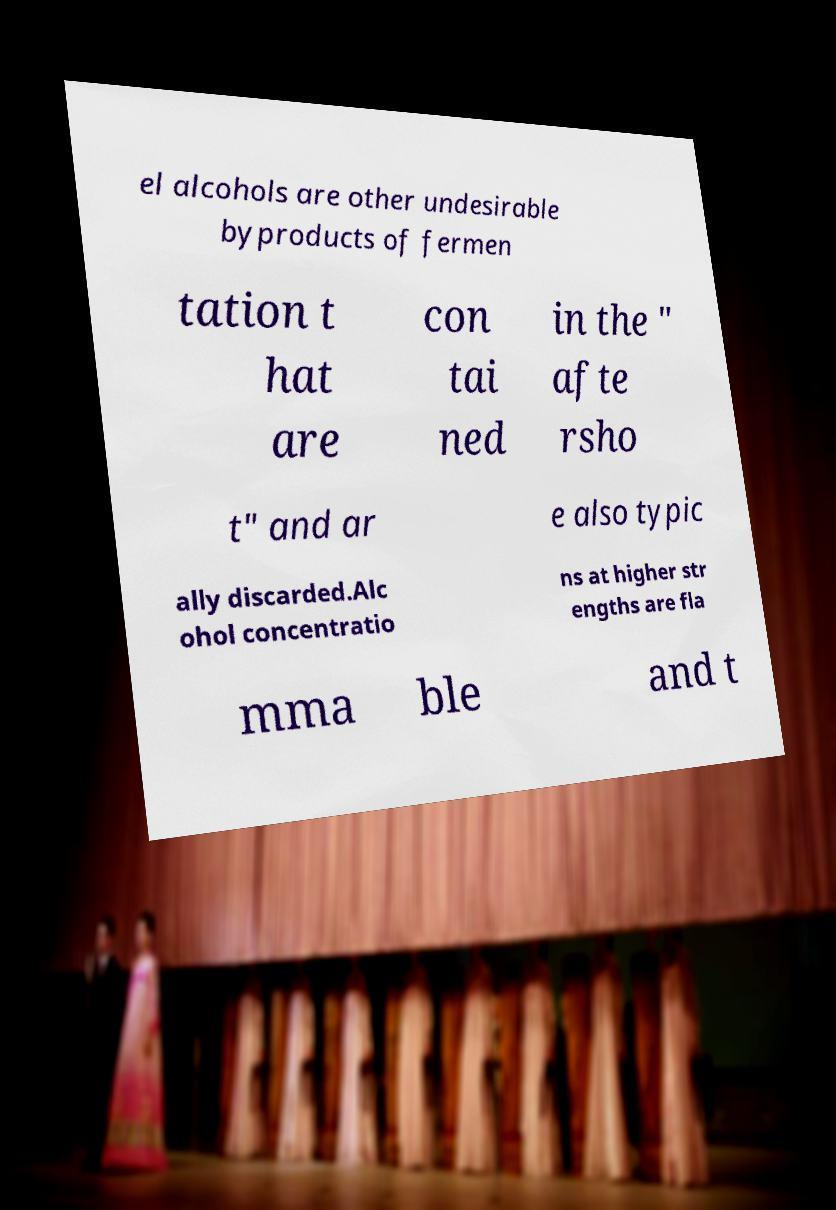What messages or text are displayed in this image? I need them in a readable, typed format. el alcohols are other undesirable byproducts of fermen tation t hat are con tai ned in the " afte rsho t" and ar e also typic ally discarded.Alc ohol concentratio ns at higher str engths are fla mma ble and t 